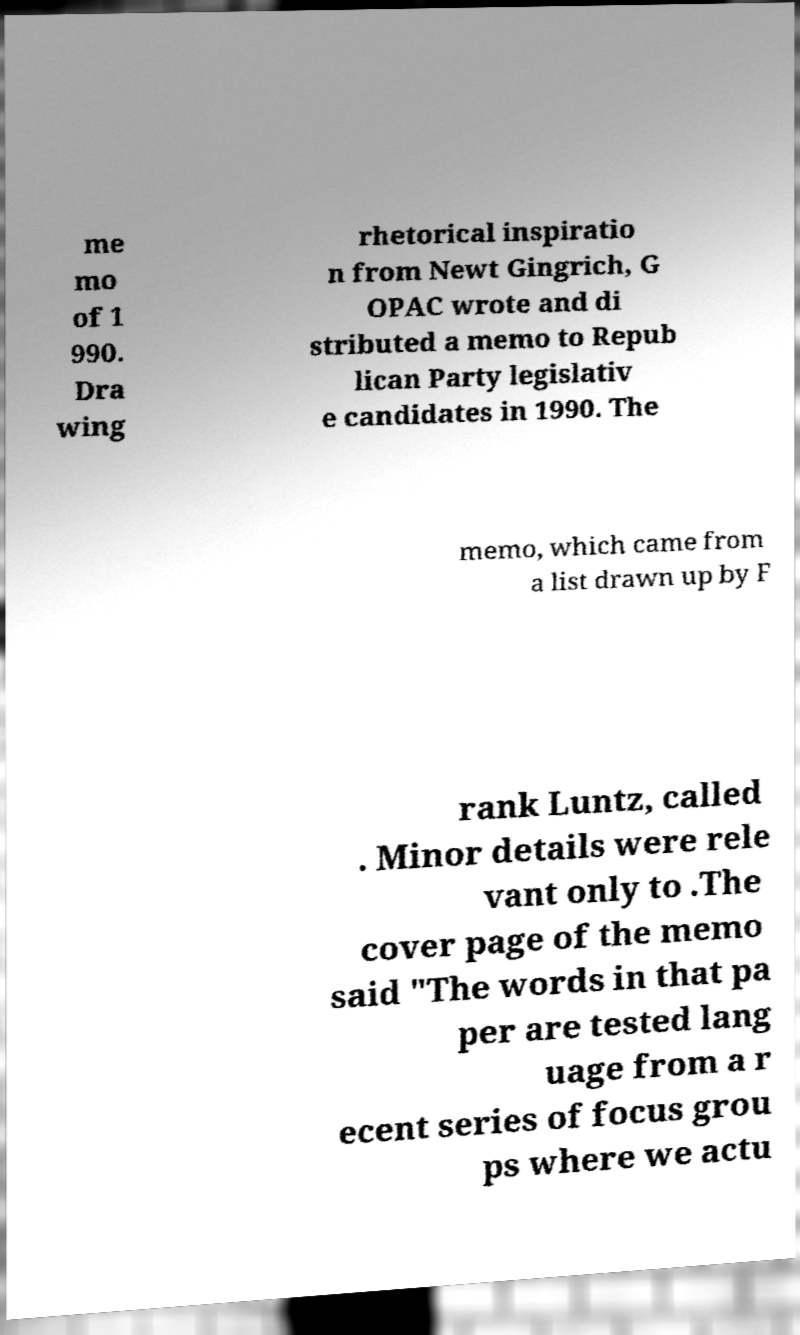I need the written content from this picture converted into text. Can you do that? me mo of 1 990. Dra wing rhetorical inspiratio n from Newt Gingrich, G OPAC wrote and di stributed a memo to Repub lican Party legislativ e candidates in 1990. The memo, which came from a list drawn up by F rank Luntz, called . Minor details were rele vant only to .The cover page of the memo said "The words in that pa per are tested lang uage from a r ecent series of focus grou ps where we actu 